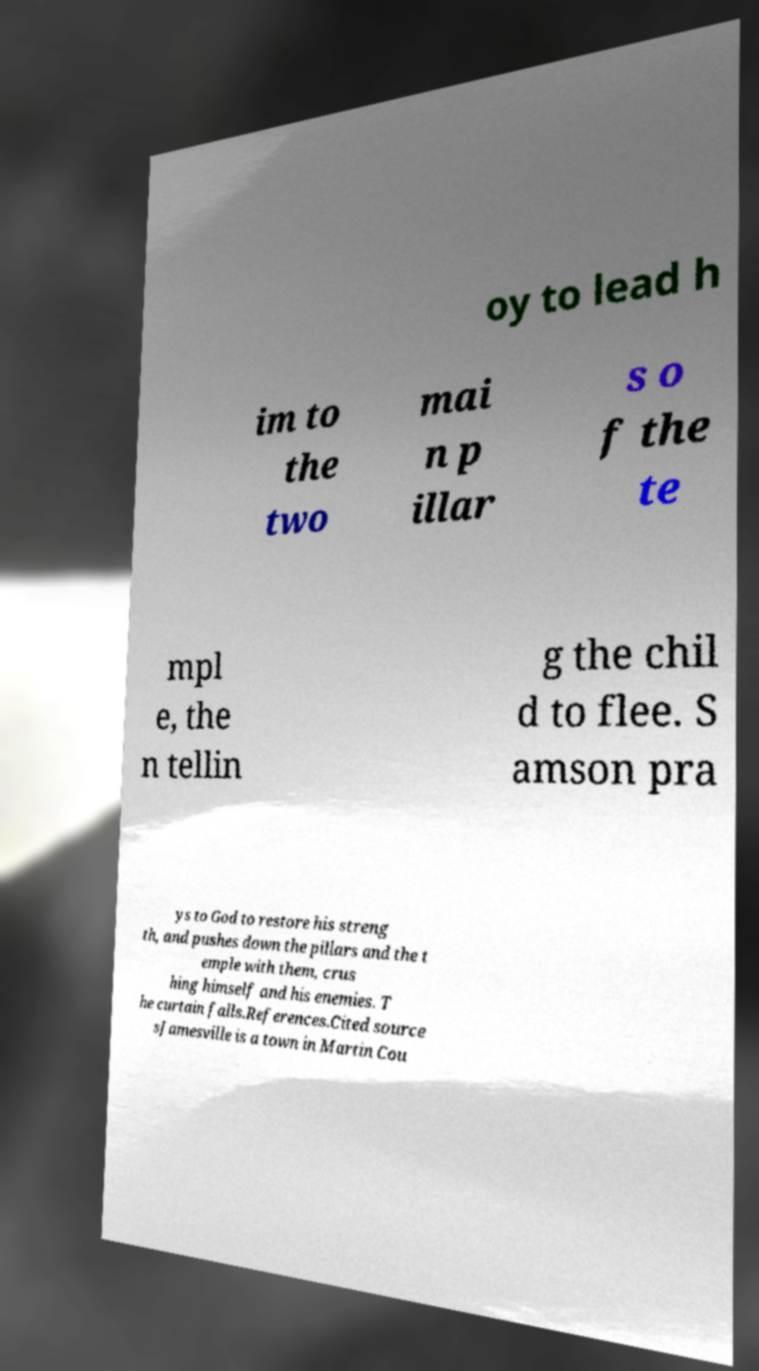Could you assist in decoding the text presented in this image and type it out clearly? oy to lead h im to the two mai n p illar s o f the te mpl e, the n tellin g the chil d to flee. S amson pra ys to God to restore his streng th, and pushes down the pillars and the t emple with them, crus hing himself and his enemies. T he curtain falls.References.Cited source sJamesville is a town in Martin Cou 